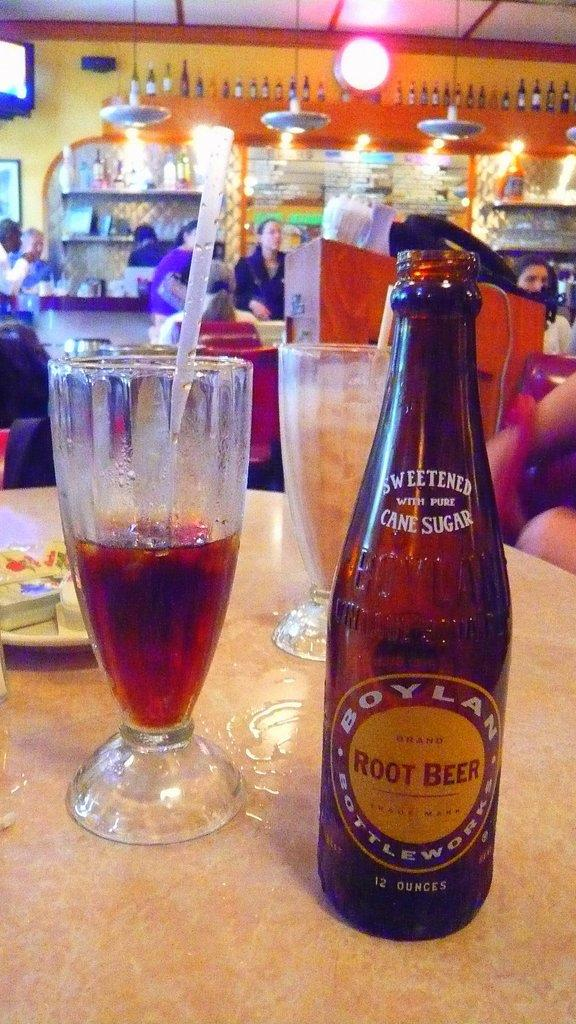<image>
Offer a succinct explanation of the picture presented. An open bottle of Boylan Root Beer next to a half full glass with a straw. 